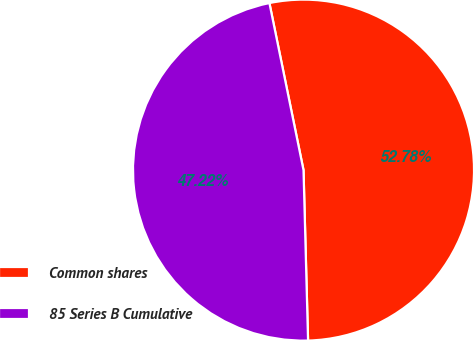<chart> <loc_0><loc_0><loc_500><loc_500><pie_chart><fcel>Common shares<fcel>85 Series B Cumulative<nl><fcel>52.78%<fcel>47.22%<nl></chart> 